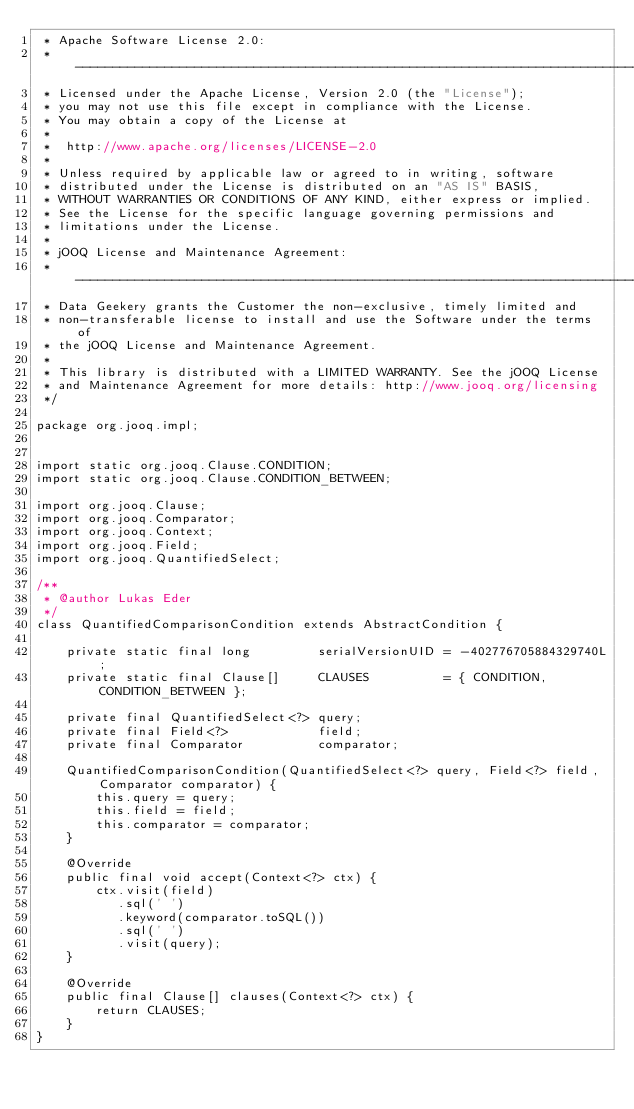Convert code to text. <code><loc_0><loc_0><loc_500><loc_500><_Java_> * Apache Software License 2.0:
 * -----------------------------------------------------------------------------
 * Licensed under the Apache License, Version 2.0 (the "License");
 * you may not use this file except in compliance with the License.
 * You may obtain a copy of the License at
 *
 *  http://www.apache.org/licenses/LICENSE-2.0
 *
 * Unless required by applicable law or agreed to in writing, software
 * distributed under the License is distributed on an "AS IS" BASIS,
 * WITHOUT WARRANTIES OR CONDITIONS OF ANY KIND, either express or implied.
 * See the License for the specific language governing permissions and
 * limitations under the License.
 *
 * jOOQ License and Maintenance Agreement:
 * -----------------------------------------------------------------------------
 * Data Geekery grants the Customer the non-exclusive, timely limited and
 * non-transferable license to install and use the Software under the terms of
 * the jOOQ License and Maintenance Agreement.
 *
 * This library is distributed with a LIMITED WARRANTY. See the jOOQ License
 * and Maintenance Agreement for more details: http://www.jooq.org/licensing
 */

package org.jooq.impl;


import static org.jooq.Clause.CONDITION;
import static org.jooq.Clause.CONDITION_BETWEEN;

import org.jooq.Clause;
import org.jooq.Comparator;
import org.jooq.Context;
import org.jooq.Field;
import org.jooq.QuantifiedSelect;

/**
 * @author Lukas Eder
 */
class QuantifiedComparisonCondition extends AbstractCondition {

    private static final long         serialVersionUID = -402776705884329740L;
    private static final Clause[]     CLAUSES          = { CONDITION, CONDITION_BETWEEN };

    private final QuantifiedSelect<?> query;
    private final Field<?>            field;
    private final Comparator          comparator;

    QuantifiedComparisonCondition(QuantifiedSelect<?> query, Field<?> field, Comparator comparator) {
        this.query = query;
        this.field = field;
        this.comparator = comparator;
    }

    @Override
    public final void accept(Context<?> ctx) {
        ctx.visit(field)
           .sql(' ')
           .keyword(comparator.toSQL())
           .sql(' ')
           .visit(query);
    }

    @Override
    public final Clause[] clauses(Context<?> ctx) {
        return CLAUSES;
    }
}
</code> 